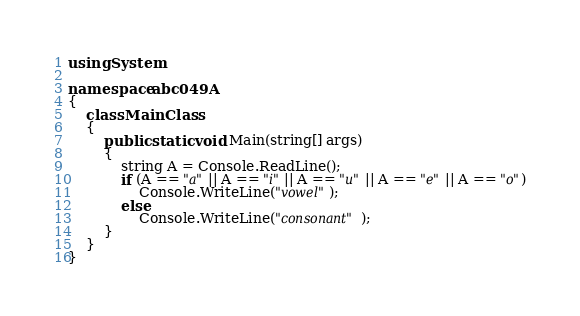Convert code to text. <code><loc_0><loc_0><loc_500><loc_500><_C#_>using System;

namespace abc049A
{
    class MainClass
    {
        public static void Main(string[] args)
        {
            string A = Console.ReadLine();
            if (A == "a" || A == "i" || A == "u" || A == "e" || A == "o")
                Console.WriteLine("vowel");
            else
                Console.WriteLine("consonant");
        }
    }
}
</code> 